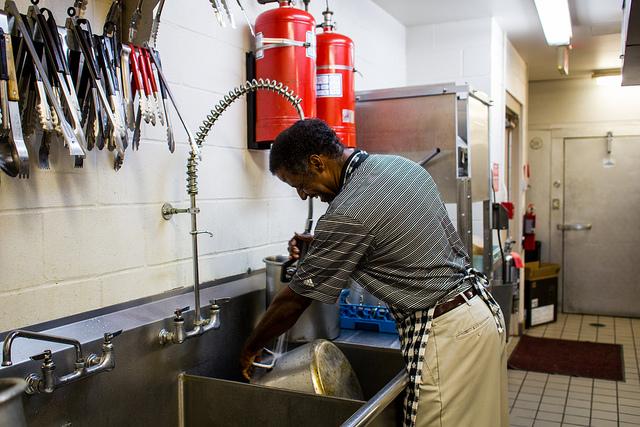Is this a commercial kitchen?
Quick response, please. Yes. What is this man's job title?
Be succinct. Dishwasher. What are the large red objects used for?
Keep it brief. Fire extinguishers. 